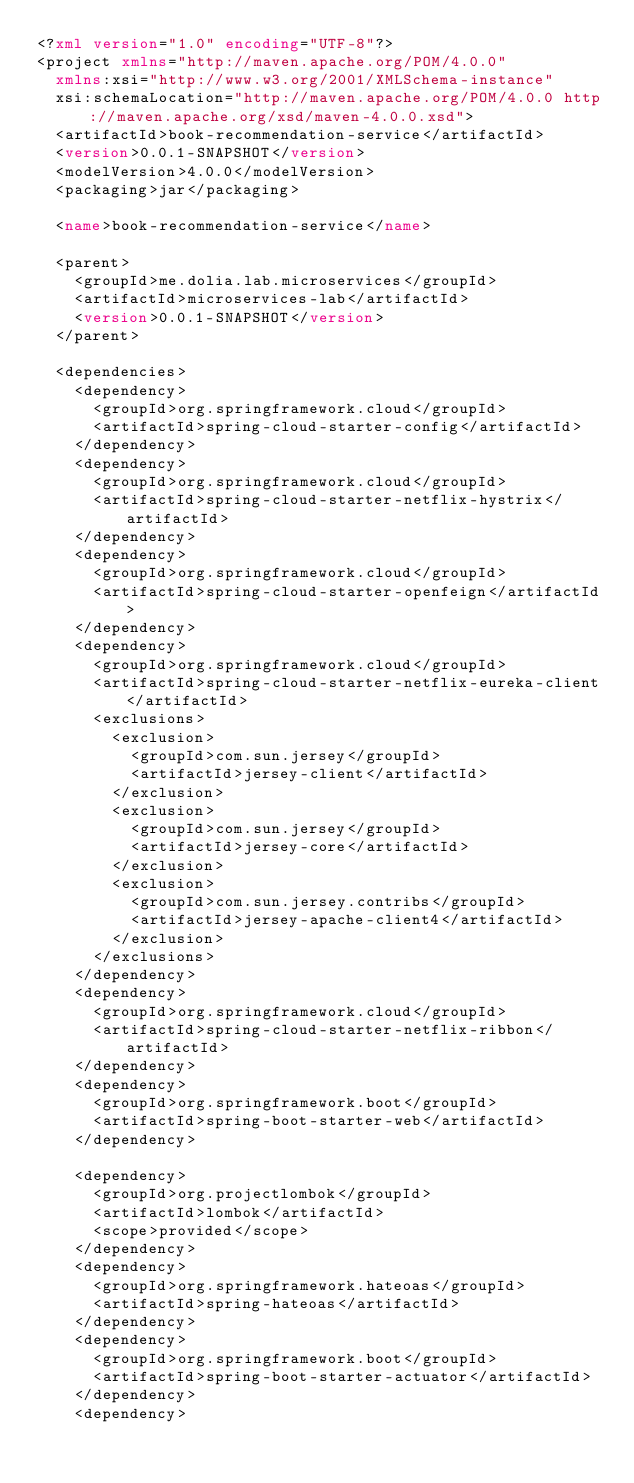Convert code to text. <code><loc_0><loc_0><loc_500><loc_500><_XML_><?xml version="1.0" encoding="UTF-8"?>
<project xmlns="http://maven.apache.org/POM/4.0.0"
  xmlns:xsi="http://www.w3.org/2001/XMLSchema-instance"
  xsi:schemaLocation="http://maven.apache.org/POM/4.0.0 http://maven.apache.org/xsd/maven-4.0.0.xsd">
  <artifactId>book-recommendation-service</artifactId>
  <version>0.0.1-SNAPSHOT</version>
  <modelVersion>4.0.0</modelVersion>
  <packaging>jar</packaging>

  <name>book-recommendation-service</name>

  <parent>
    <groupId>me.dolia.lab.microservices</groupId>
    <artifactId>microservices-lab</artifactId>
    <version>0.0.1-SNAPSHOT</version>
  </parent>

  <dependencies>
    <dependency>
      <groupId>org.springframework.cloud</groupId>
      <artifactId>spring-cloud-starter-config</artifactId>
    </dependency>
    <dependency>
      <groupId>org.springframework.cloud</groupId>
      <artifactId>spring-cloud-starter-netflix-hystrix</artifactId>
    </dependency>
    <dependency>
      <groupId>org.springframework.cloud</groupId>
      <artifactId>spring-cloud-starter-openfeign</artifactId>
    </dependency>
    <dependency>
      <groupId>org.springframework.cloud</groupId>
      <artifactId>spring-cloud-starter-netflix-eureka-client</artifactId>
      <exclusions>
        <exclusion>
          <groupId>com.sun.jersey</groupId>
          <artifactId>jersey-client</artifactId>
        </exclusion>
        <exclusion>
          <groupId>com.sun.jersey</groupId>
          <artifactId>jersey-core</artifactId>
        </exclusion>
        <exclusion>
          <groupId>com.sun.jersey.contribs</groupId>
          <artifactId>jersey-apache-client4</artifactId>
        </exclusion>
      </exclusions>
    </dependency>
    <dependency>
      <groupId>org.springframework.cloud</groupId>
      <artifactId>spring-cloud-starter-netflix-ribbon</artifactId>
    </dependency>
    <dependency>
      <groupId>org.springframework.boot</groupId>
      <artifactId>spring-boot-starter-web</artifactId>
    </dependency>

    <dependency>
      <groupId>org.projectlombok</groupId>
      <artifactId>lombok</artifactId>
      <scope>provided</scope>
    </dependency>
    <dependency>
      <groupId>org.springframework.hateoas</groupId>
      <artifactId>spring-hateoas</artifactId>
    </dependency>
    <dependency>
      <groupId>org.springframework.boot</groupId>
      <artifactId>spring-boot-starter-actuator</artifactId>
    </dependency>
    <dependency></code> 